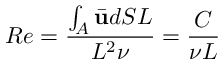<formula> <loc_0><loc_0><loc_500><loc_500>R e = \frac { \int _ { A } \bar { u } d S L } { L ^ { 2 } \nu } = \frac { C } { \nu L }</formula> 